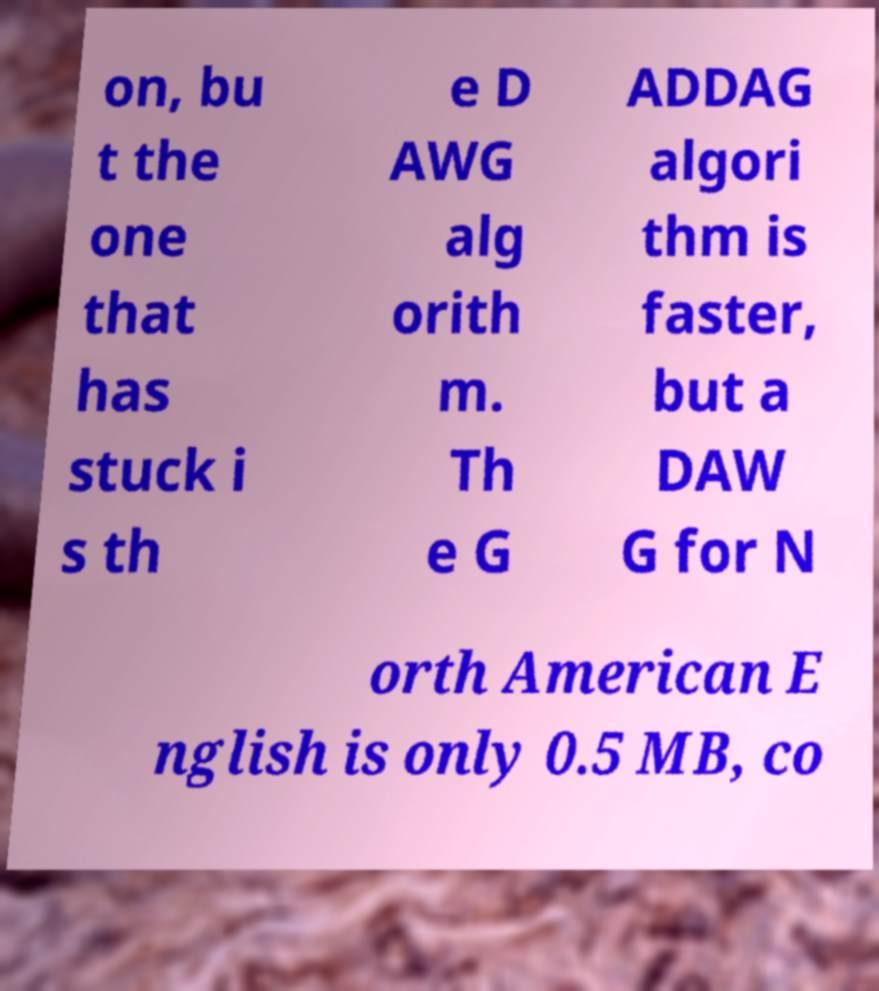Please read and relay the text visible in this image. What does it say? on, bu t the one that has stuck i s th e D AWG alg orith m. Th e G ADDAG algori thm is faster, but a DAW G for N orth American E nglish is only 0.5 MB, co 